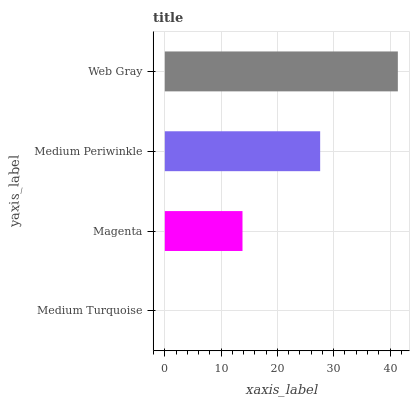Is Medium Turquoise the minimum?
Answer yes or no. Yes. Is Web Gray the maximum?
Answer yes or no. Yes. Is Magenta the minimum?
Answer yes or no. No. Is Magenta the maximum?
Answer yes or no. No. Is Magenta greater than Medium Turquoise?
Answer yes or no. Yes. Is Medium Turquoise less than Magenta?
Answer yes or no. Yes. Is Medium Turquoise greater than Magenta?
Answer yes or no. No. Is Magenta less than Medium Turquoise?
Answer yes or no. No. Is Medium Periwinkle the high median?
Answer yes or no. Yes. Is Magenta the low median?
Answer yes or no. Yes. Is Magenta the high median?
Answer yes or no. No. Is Medium Turquoise the low median?
Answer yes or no. No. 